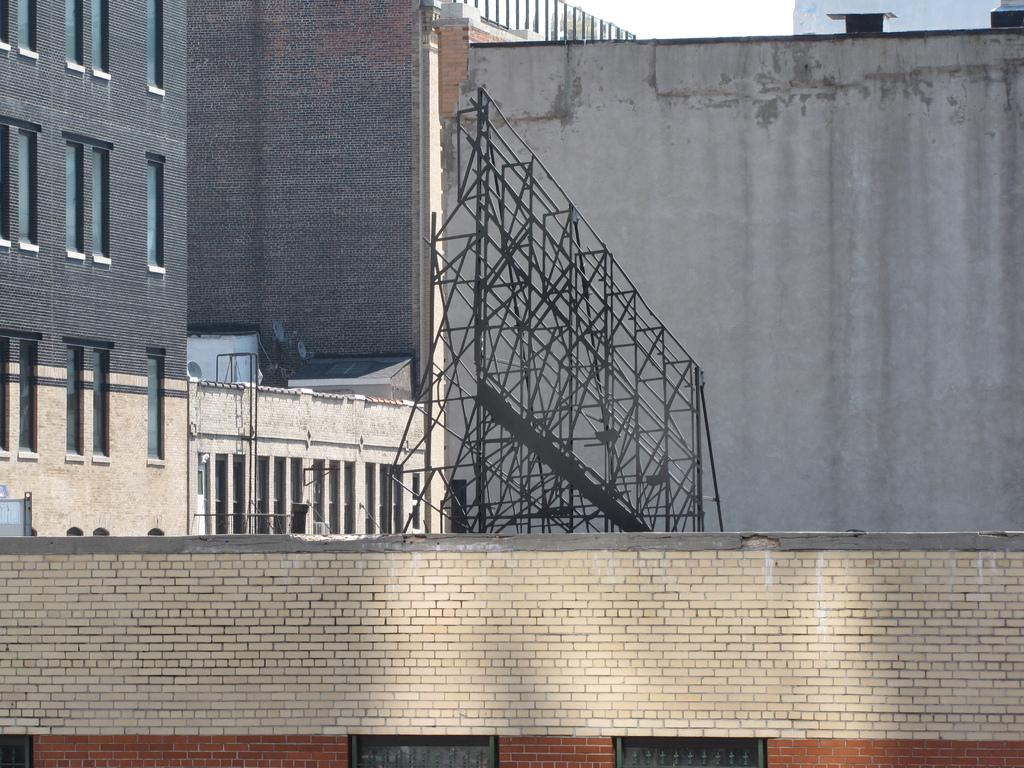What type of structure is at the bottom of the image? There is a brick wall at the bottom of the image. What can be seen in the center of the image? Buildings, iron frames, pipes, and windows are visible in the center of the image. Can you describe the other objects present in the center of the image? There are other objects in the center of the image, but their specific details are not mentioned in the provided facts. What is visible at the top of the image? The sky is visible at the top of the image. How many pies are being baked in the brick oven in the image? There is no brick oven or pies present in the image. What type of rock is being used to construct the buildings in the image? The buildings in the image are made of bricks, not rock. 